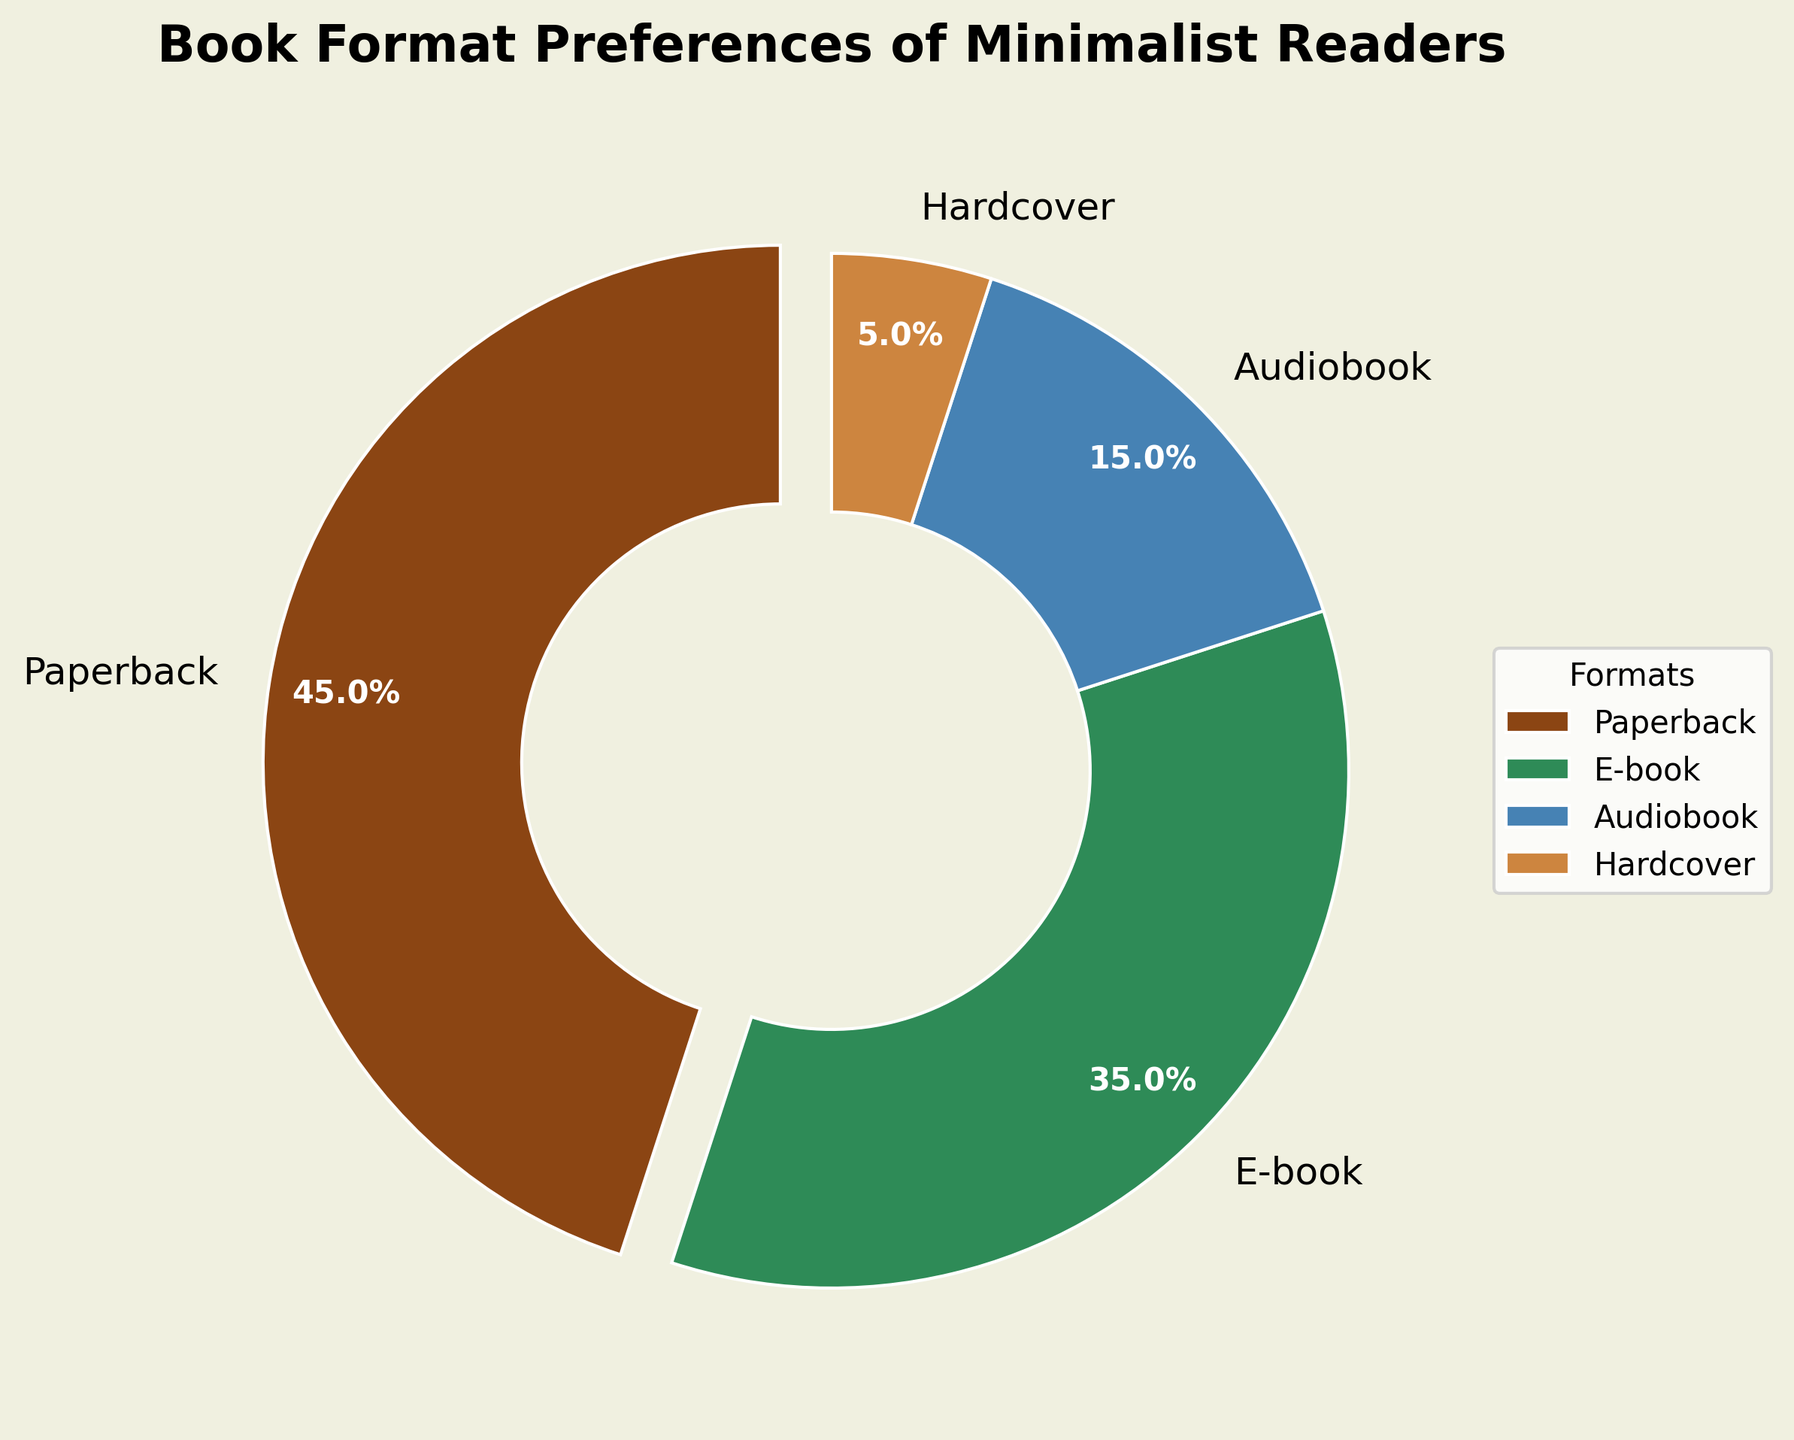What format has the highest percentage preference among minimalist readers? The slice representing paperbacks takes up the largest portion of the pie chart, marked with the label showing 45%.
Answer: Paperback What percentage of minimalist readers prefer digital formats (e-books and audiobooks combined)? To determine this, sum the percentages for e-books and audiobooks: 35% (e-books) + 15% (audiobooks) = 50%.
Answer: 50% Which book format has the smallest percentage preference? The slice representing hardcovers is the smallest, marked with the label showing 5%.
Answer: Hardcover How does the percentage of minimalist readers who prefer paperbacks compare to those who prefer e-books? Paperbacks account for 45%, while e-books account for 35%. Therefore, more minimalist readers prefer paperbacks over e-books by a margin of 45% - 35% = 10%.
Answer: Paperbacks are preferred by 10% more readers What is the combined percentage of readers who prefer tangible book formats (hardcover and paperback)? Sum the percentages for hardcovers and paperbacks: 5% (hardcover) + 45% (paperback) = 50%.
Answer: 50% Which format has a higher preference, audiobooks or hardcovers, and by how much? Audiobooks have a preference of 15%, while hardcovers have a preference of 5%. The difference is 15% - 5% = 10%.
Answer: Audiobooks by 10% If you were to color code the formats using the colors brown for paperbacks, green for e-books, blue for audiobooks, and tan for hardcovers, which format corresponds to the tan color? The tan color slice represents hardcovers as seen in the legend.
Answer: Hardcover What is the average preference percentage for all book formats? Sum all the percentages and divide by the number of formats: (45% + 35% + 15% + 5%) / 4 = 100% / 4 = 25%.
Answer: 25% By how much does the preference for e-books exceed the sum of preferences for audiobooks and hardcovers? Sum the preferences for audiobooks (15%) and hardcovers (5%), which totals 20%. E-books are preferred by 35%, so the difference is 35% - 20% = 15%.
Answer: 15% Which format has a preference percentage closest to the median of all preferences? Sort the percentages: 5%, 15%, 35%, 45%. The median of these four values (the average of 15% and 35%) is (15% + 35%) / 2 = 25%, which is closest to audiobooks (15%) and e-books (35%). Therefore, it's e-books, as 35% is closer to 25% than 15%.
Answer: E-book 